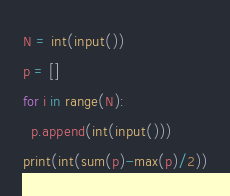<code> <loc_0><loc_0><loc_500><loc_500><_Python_>N = int(input())
p = []
for i in range(N):
  p.append(int(input()))
print(int(sum(p)-max(p)/2))</code> 